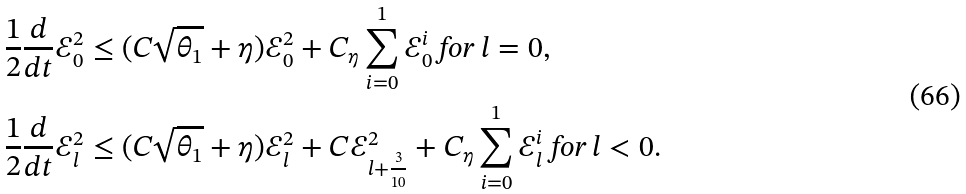<formula> <loc_0><loc_0><loc_500><loc_500>& \frac { 1 } { 2 } \frac { d } { d t } \mathcal { E } _ { 0 } ^ { 2 } \leq ( C \sqrt { \theta _ { 1 } } + \eta ) \mathcal { E } _ { 0 } ^ { 2 } + C _ { \eta } \sum _ { i = 0 } ^ { 1 } \mathcal { E } _ { 0 } ^ { i } \text { for } l = 0 , \\ & \frac { 1 } { 2 } \frac { d } { d t } \mathcal { E } _ { l } ^ { 2 } \leq ( C \sqrt { \theta _ { 1 } } + \eta ) \mathcal { E } _ { l } ^ { 2 } + C \mathcal { E } _ { l + \frac { 3 } { 1 0 } } ^ { 2 } + C _ { \eta } \sum _ { i = 0 } ^ { 1 } \mathcal { E } _ { l } ^ { i } \text { for } l < 0 .</formula> 